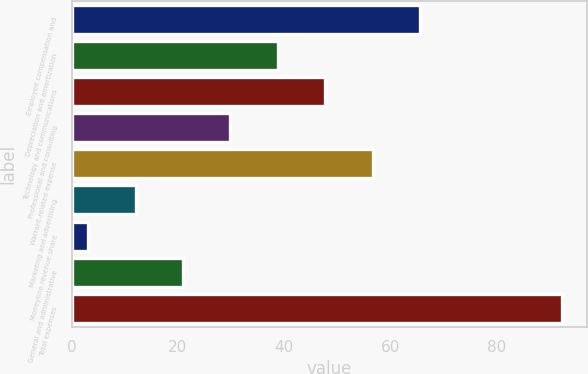<chart> <loc_0><loc_0><loc_500><loc_500><bar_chart><fcel>Employee compensation and<fcel>Depreciation and amortization<fcel>Technology and communications<fcel>Professional and consulting<fcel>Warrant-related expense<fcel>Marketing and advertising<fcel>Moneyline revenue share<fcel>General and administrative<fcel>Total expenses<nl><fcel>65.61<fcel>38.82<fcel>47.75<fcel>29.89<fcel>56.68<fcel>12.03<fcel>3.1<fcel>20.96<fcel>92.4<nl></chart> 